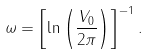<formula> <loc_0><loc_0><loc_500><loc_500>\omega = \left [ \ln { \left ( \frac { V _ { 0 } } { 2 \pi } \right ) } \right ] ^ { - 1 } .</formula> 